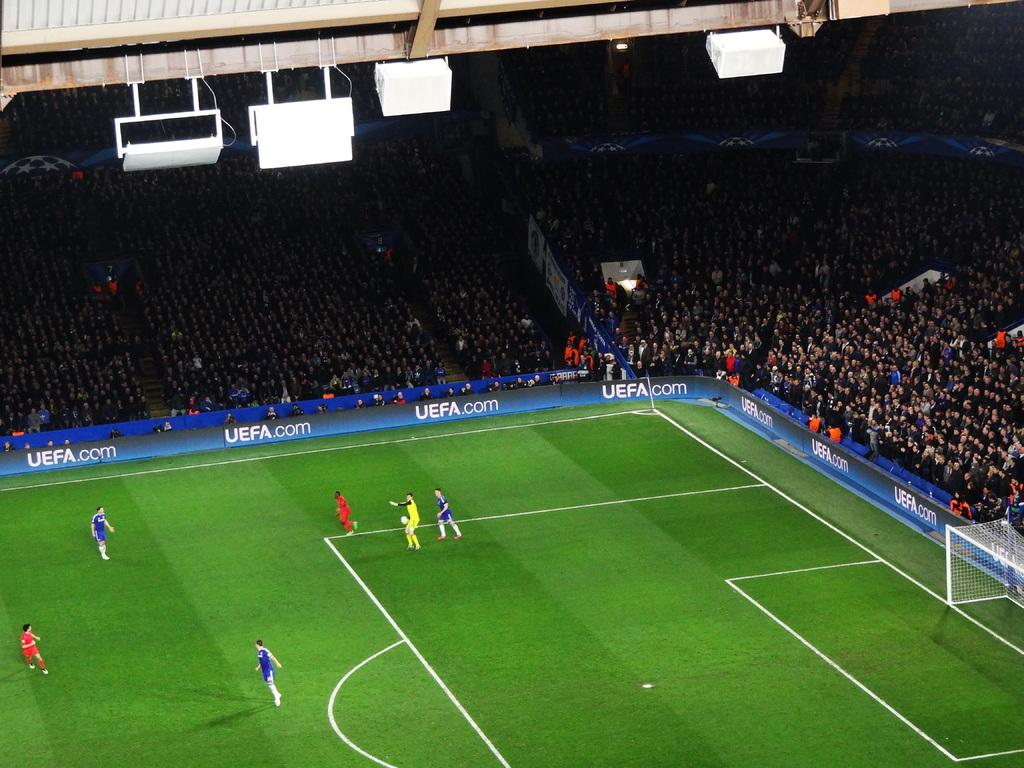<image>
Give a short and clear explanation of the subsequent image. Soccer field that has an ad that says UEFA. 